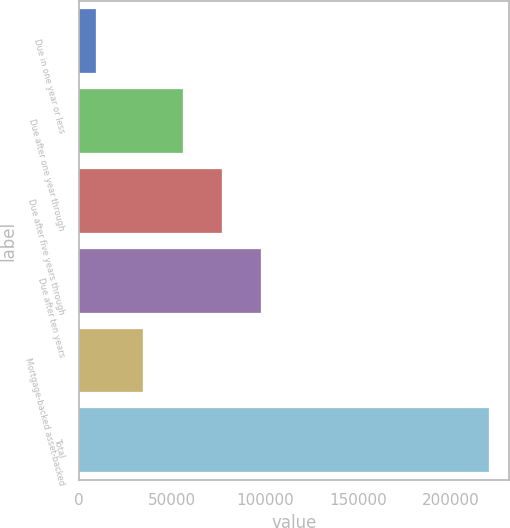Convert chart to OTSL. <chart><loc_0><loc_0><loc_500><loc_500><bar_chart><fcel>Due in one year or less<fcel>Due after one year through<fcel>Due after five years through<fcel>Due after ten years<fcel>Mortgage-backed asset-backed<fcel>Total<nl><fcel>8940<fcel>55796.9<fcel>76969.8<fcel>98142.7<fcel>34624<fcel>220669<nl></chart> 